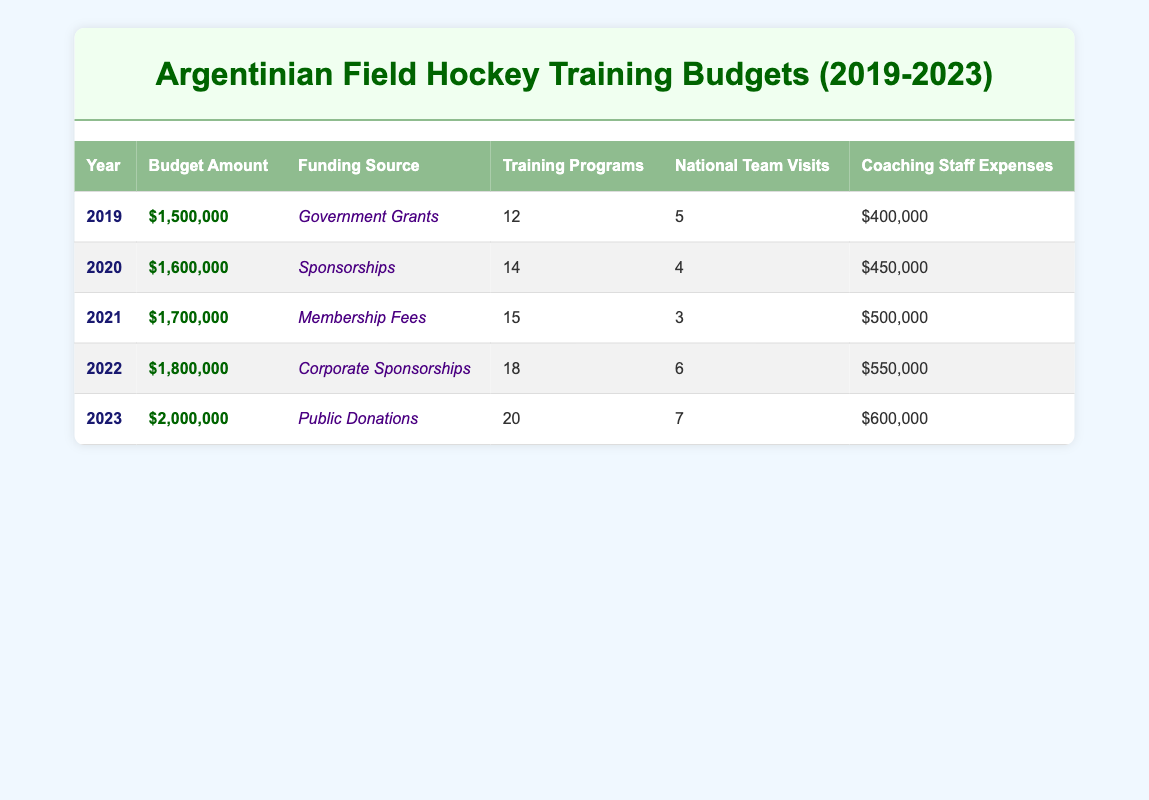What was the budget amount for Argentinian field hockey in 2020? The table shows the budget amounts for each year. For the year 2020, the corresponding budget amount is clearly listed as $1,600,000.
Answer: $1,600,000 How many training programs were offered in 2021? By looking at the table, we can find the entry for the year 2021 and see that the number of training programs is listed as 15.
Answer: 15 Did the coaching staff expenses increase from 2019 to 2023? The table can be referenced for coaching staff expenses in both years. In 2019, coaching staff expenses were $400,000, and in 2023, they were $600,000. Since $600,000 is greater than $400,000, we can confirm that there was an increase.
Answer: Yes What is the total budget amount for the years 2019 to 2023? The budget amounts for each year are $1,500,000 (2019), $1,600,000 (2020), $1,700,000 (2021), $1,800,000 (2022), and $2,000,000 (2023). Adding these amounts gives us a total of (1,500,000 + 1,600,000 + 1,700,000 + 1,800,000 + 2,000,000) = $8,600,000.
Answer: $8,600,000 How many national team visits were there in total between 2019 and 2023? The number of national team visits for each year is recorded as 5 (2019), 4 (2020), 3 (2021), 6 (2022), and 7 (2023). Adding these gives the total national team visits as (5 + 4 + 3 + 6 + 7) = 25.
Answer: 25 In which year was the highest number of training programs offered? The number of training programs for each year is 12 (2019), 14 (2020), 15 (2021), 18 (2022), and 20 (2023). By finding the maximum number from these values, it is clear that 20 in 2023 is the highest.
Answer: 2023 Is the funding source for 2022 "Corporate Sponsorships"? The funding source for the year 2022 in the table is identified as "Corporate Sponsorships". Therefore, the statement is true.
Answer: Yes Which year had the lowest coaching staff expenses? The coaching staff expenses listed for each year are $400,000 (2019), $450,000 (2020), $500,000 (2021), $550,000 (2022), and $600,000 (2023). The lowest amount is easily identified as $400,000 in 2019.
Answer: 2019 